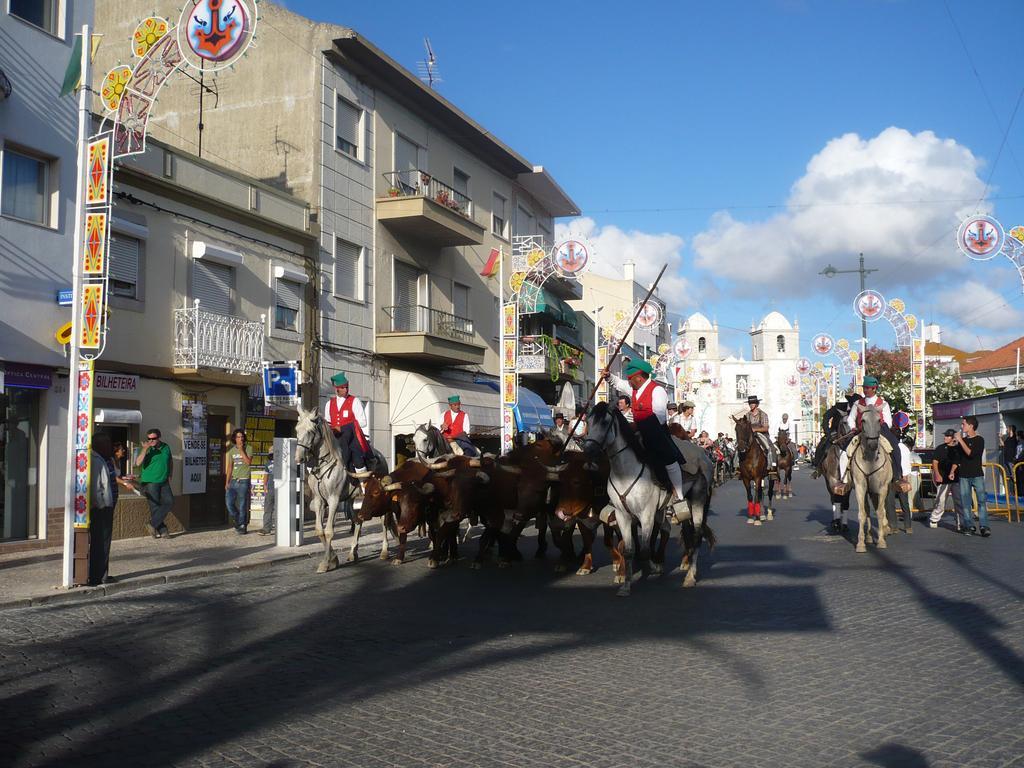Could you give a brief overview of what you see in this image? In this picture I can observe some horses and bulls which are in brown color on the road. There are some people sitting on the horses. On the left side I can observe a pole. In the background there are buildings and I can observe clouds in the sky. 